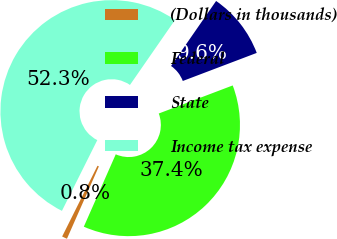Convert chart to OTSL. <chart><loc_0><loc_0><loc_500><loc_500><pie_chart><fcel>(Dollars in thousands)<fcel>Federal<fcel>State<fcel>Income tax expense<nl><fcel>0.76%<fcel>37.39%<fcel>9.58%<fcel>52.27%<nl></chart> 